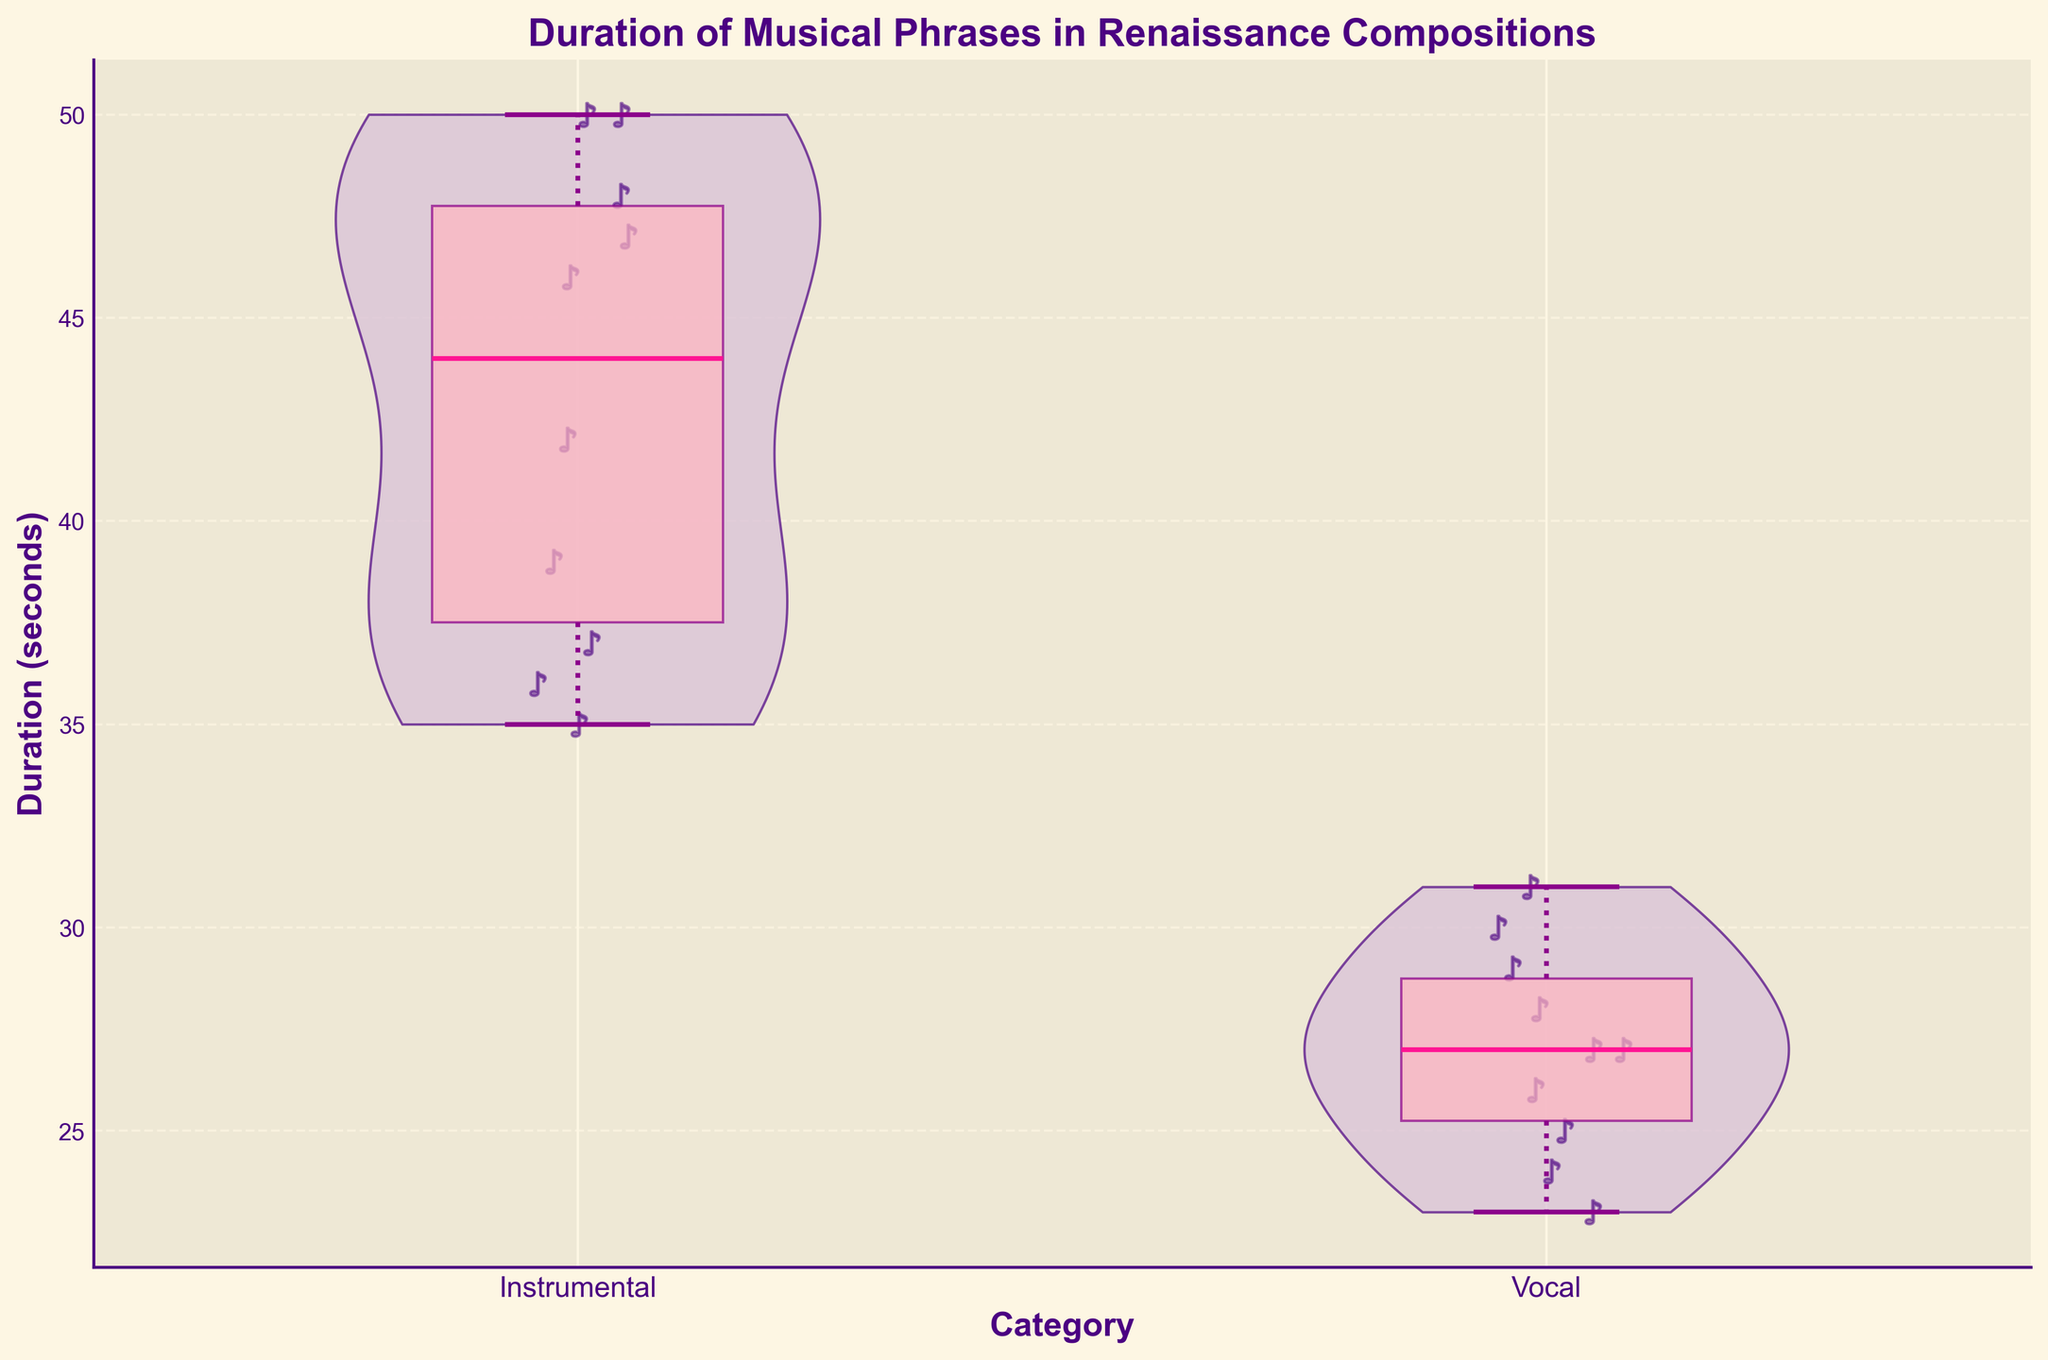What's the maximum duration for Instrumental compositions? The highest point in the violin plot for Instrumental compositions represents the maximum duration. This value is approximately 50 seconds.
Answer: 50 seconds What's the median duration of Vocal compositions? To find the median, refer to the line inside the box of the Box Plot for Vocal compositions. The median value is approximately 27.
Answer: 27 seconds Which category has a wider range of durations? The range of durations can be observed by looking at the spread of the violin plots and the whiskers in the Box Plot. Instrumental compositions show a wider range of durations compared to Vocal.
Answer: Instrumental How many data points represent Vocal compositions? Each scatter point on the violin plot represents a data point. By counting the music note scatter points in the Vocal category, you can see there are 10 data points.
Answer: 10 data points What is the interquartile range (IQR) for Instrumental compositions? The IQR is found by subtracting the 25th percentile value (bottom of the box) from the 75th percentile value (top of the box) in the Box Plot. The 75th percentile is around 48, and the 25th percentile is around 36, so the IQR is 48 - 36 = 12.
Answer: 12 Which category has compositions with shorter durations? By comparing the location of the median lines and the heights of the violin plots, it's evident that Vocal compositions have generally shorter durations.
Answer: Vocal What's the average duration for Instrumental compositions? Sum the durations for Instrumental compositions and divide by the number of pieces. The total duration is (42 + 47 + 39 + 50 + 35 + 46 + 48 + 50 + 36 + 37) = 430. Divide 430 by 10 (number of entries), resulting in an average of 43.
Answer: 43 seconds What is the duration of the shortest instrumental piece? The lowest point on the violin plot represents the minimum duration. For Instrumental compositions, the minimum duration is around 35 seconds.
Answer: 35 seconds 